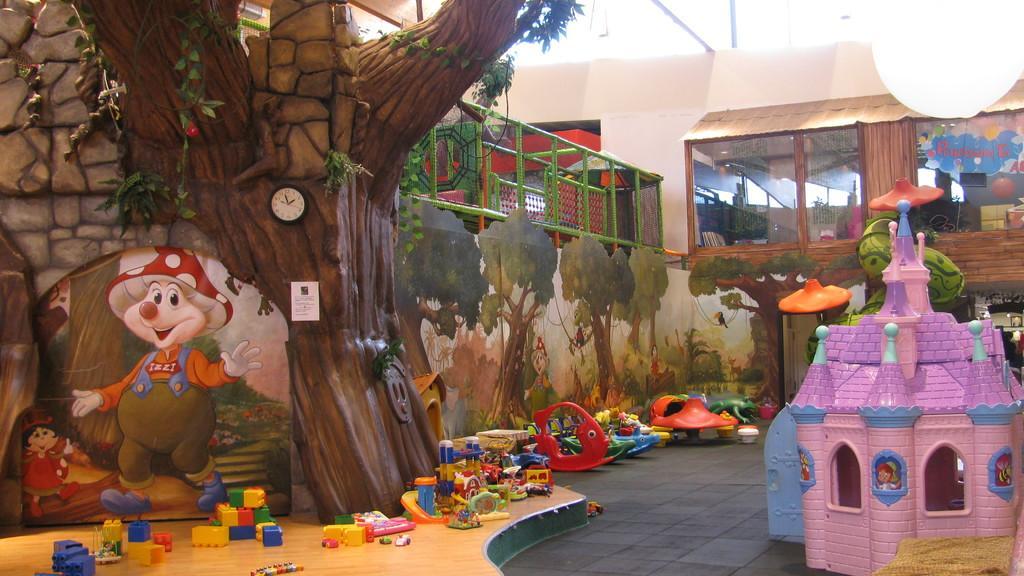In one or two sentences, can you explain what this image depicts? In the image we can see toys on the floor, stone wall, clock and the wall where a tree sculpture is made. Here we can see the railing, glass windows, building and lights to the ceiling in the background. 